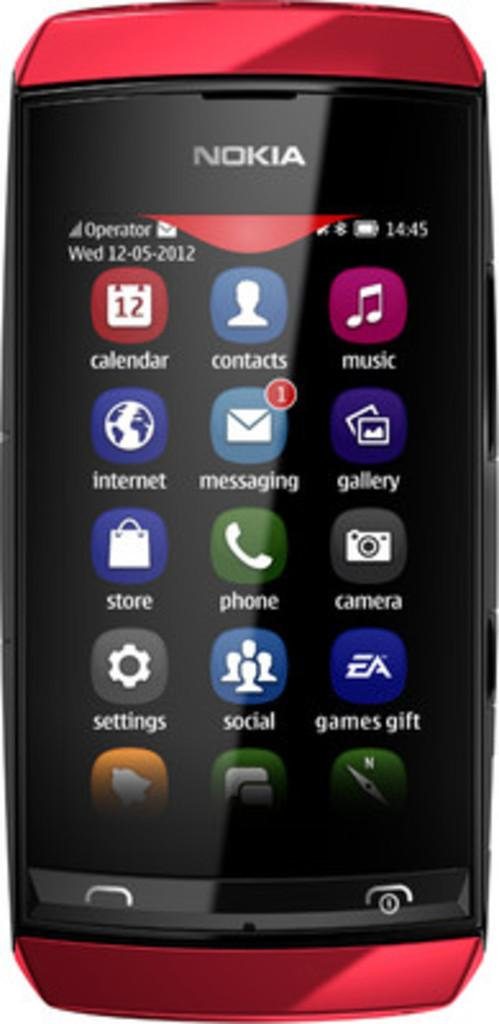<image>
Share a concise interpretation of the image provided. A red and black cell phone from the brand Nokia has multiple apps on the screen. 